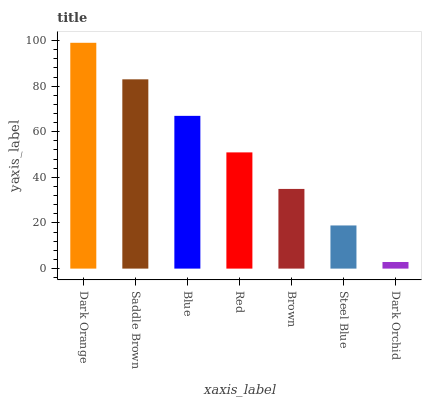Is Dark Orchid the minimum?
Answer yes or no. Yes. Is Dark Orange the maximum?
Answer yes or no. Yes. Is Saddle Brown the minimum?
Answer yes or no. No. Is Saddle Brown the maximum?
Answer yes or no. No. Is Dark Orange greater than Saddle Brown?
Answer yes or no. Yes. Is Saddle Brown less than Dark Orange?
Answer yes or no. Yes. Is Saddle Brown greater than Dark Orange?
Answer yes or no. No. Is Dark Orange less than Saddle Brown?
Answer yes or no. No. Is Red the high median?
Answer yes or no. Yes. Is Red the low median?
Answer yes or no. Yes. Is Saddle Brown the high median?
Answer yes or no. No. Is Saddle Brown the low median?
Answer yes or no. No. 